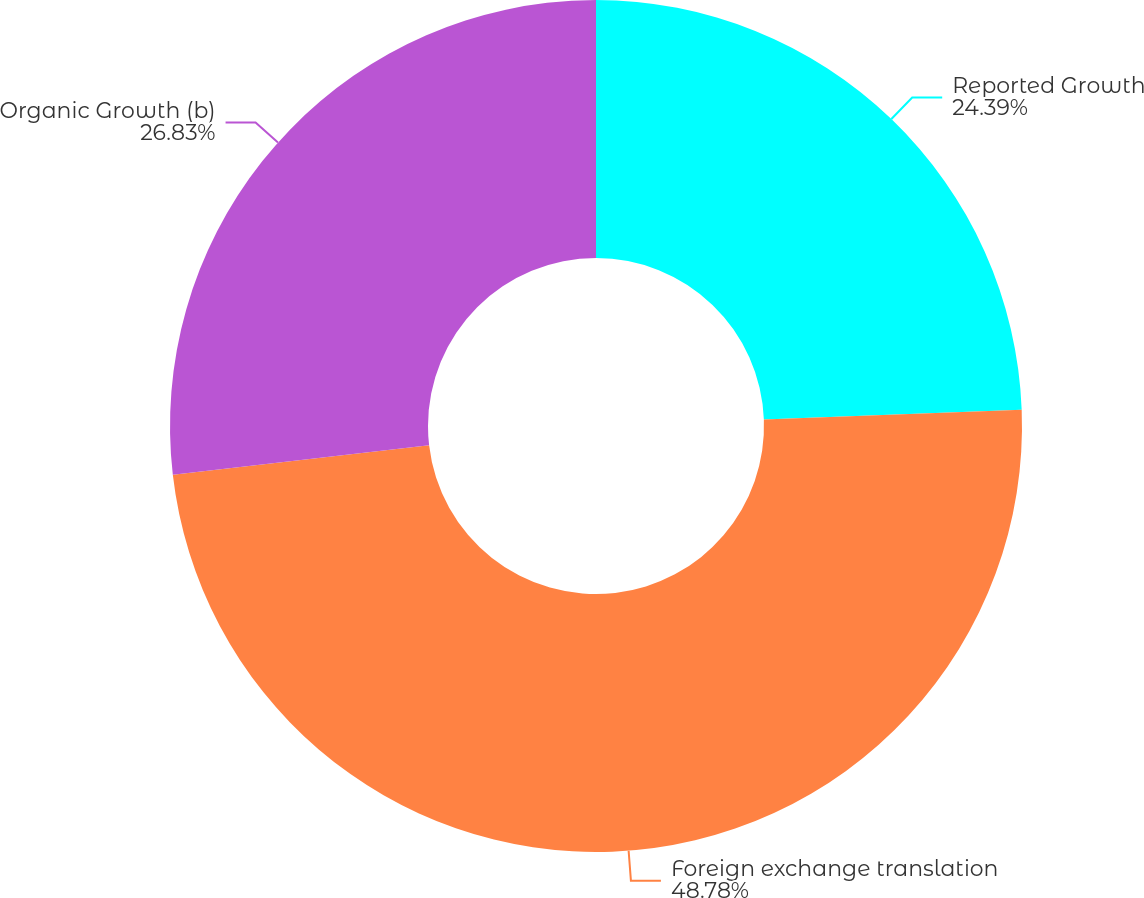<chart> <loc_0><loc_0><loc_500><loc_500><pie_chart><fcel>Reported Growth<fcel>Foreign exchange translation<fcel>Organic Growth (b)<nl><fcel>24.39%<fcel>48.78%<fcel>26.83%<nl></chart> 